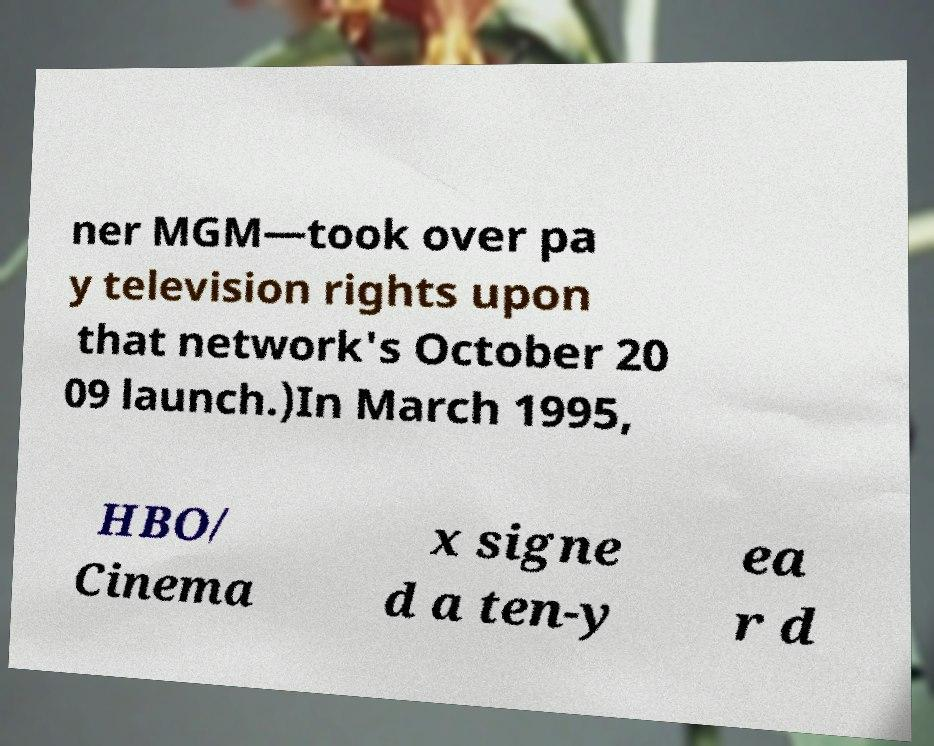There's text embedded in this image that I need extracted. Can you transcribe it verbatim? ner MGM—took over pa y television rights upon that network's October 20 09 launch.)In March 1995, HBO/ Cinema x signe d a ten-y ea r d 